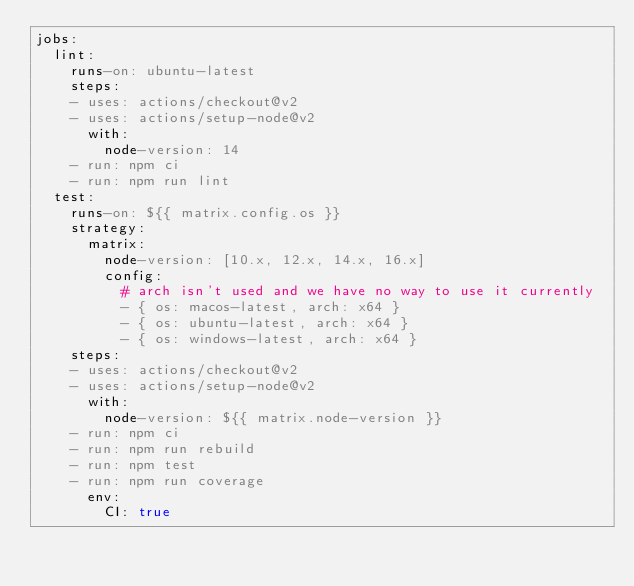<code> <loc_0><loc_0><loc_500><loc_500><_YAML_>jobs:
  lint:
    runs-on: ubuntu-latest
    steps:
    - uses: actions/checkout@v2
    - uses: actions/setup-node@v2
      with:
        node-version: 14
    - run: npm ci
    - run: npm run lint
  test:
    runs-on: ${{ matrix.config.os }}
    strategy:
      matrix:
        node-version: [10.x, 12.x, 14.x, 16.x]
        config:
          # arch isn't used and we have no way to use it currently
          - { os: macos-latest, arch: x64 }
          - { os: ubuntu-latest, arch: x64 }
          - { os: windows-latest, arch: x64 }
    steps:
    - uses: actions/checkout@v2
    - uses: actions/setup-node@v2
      with:
        node-version: ${{ matrix.node-version }}
    - run: npm ci
    - run: npm run rebuild
    - run: npm test
    - run: npm run coverage
      env:
        CI: true
</code> 